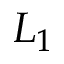Convert formula to latex. <formula><loc_0><loc_0><loc_500><loc_500>L _ { 1 }</formula> 